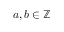<formula> <loc_0><loc_0><loc_500><loc_500>a , b \in \mathbb { Z }</formula> 